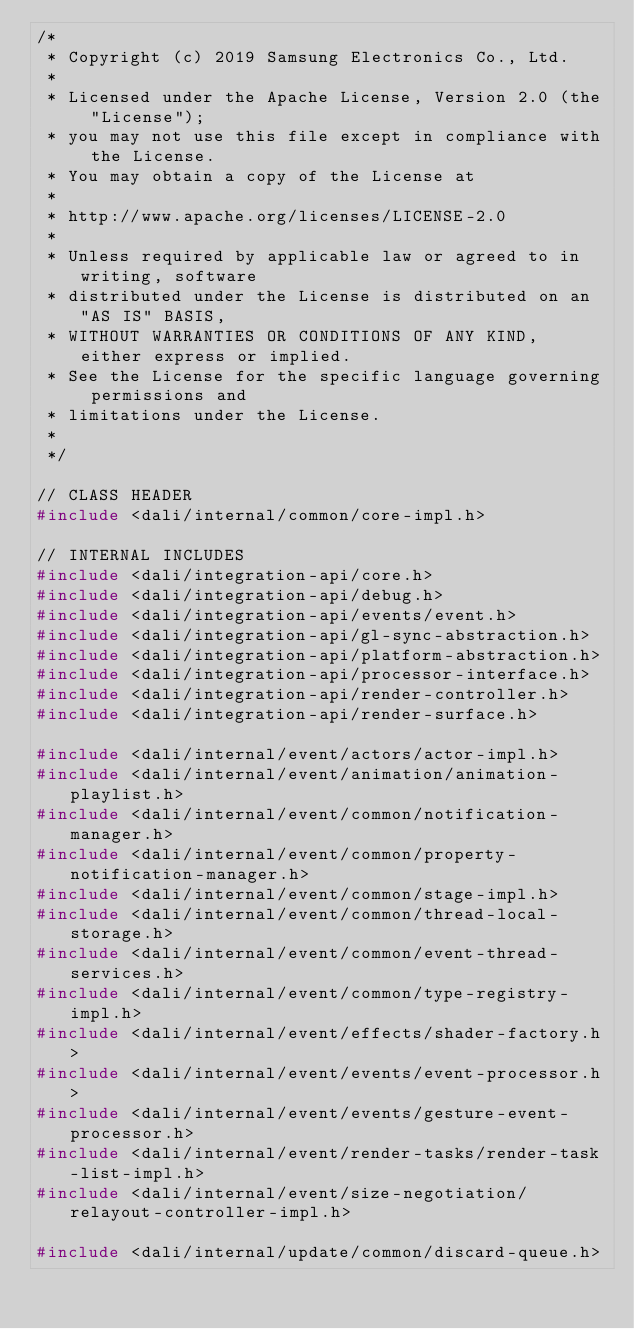<code> <loc_0><loc_0><loc_500><loc_500><_C++_>/*
 * Copyright (c) 2019 Samsung Electronics Co., Ltd.
 *
 * Licensed under the Apache License, Version 2.0 (the "License");
 * you may not use this file except in compliance with the License.
 * You may obtain a copy of the License at
 *
 * http://www.apache.org/licenses/LICENSE-2.0
 *
 * Unless required by applicable law or agreed to in writing, software
 * distributed under the License is distributed on an "AS IS" BASIS,
 * WITHOUT WARRANTIES OR CONDITIONS OF ANY KIND, either express or implied.
 * See the License for the specific language governing permissions and
 * limitations under the License.
 *
 */

// CLASS HEADER
#include <dali/internal/common/core-impl.h>

// INTERNAL INCLUDES
#include <dali/integration-api/core.h>
#include <dali/integration-api/debug.h>
#include <dali/integration-api/events/event.h>
#include <dali/integration-api/gl-sync-abstraction.h>
#include <dali/integration-api/platform-abstraction.h>
#include <dali/integration-api/processor-interface.h>
#include <dali/integration-api/render-controller.h>
#include <dali/integration-api/render-surface.h>

#include <dali/internal/event/actors/actor-impl.h>
#include <dali/internal/event/animation/animation-playlist.h>
#include <dali/internal/event/common/notification-manager.h>
#include <dali/internal/event/common/property-notification-manager.h>
#include <dali/internal/event/common/stage-impl.h>
#include <dali/internal/event/common/thread-local-storage.h>
#include <dali/internal/event/common/event-thread-services.h>
#include <dali/internal/event/common/type-registry-impl.h>
#include <dali/internal/event/effects/shader-factory.h>
#include <dali/internal/event/events/event-processor.h>
#include <dali/internal/event/events/gesture-event-processor.h>
#include <dali/internal/event/render-tasks/render-task-list-impl.h>
#include <dali/internal/event/size-negotiation/relayout-controller-impl.h>

#include <dali/internal/update/common/discard-queue.h></code> 